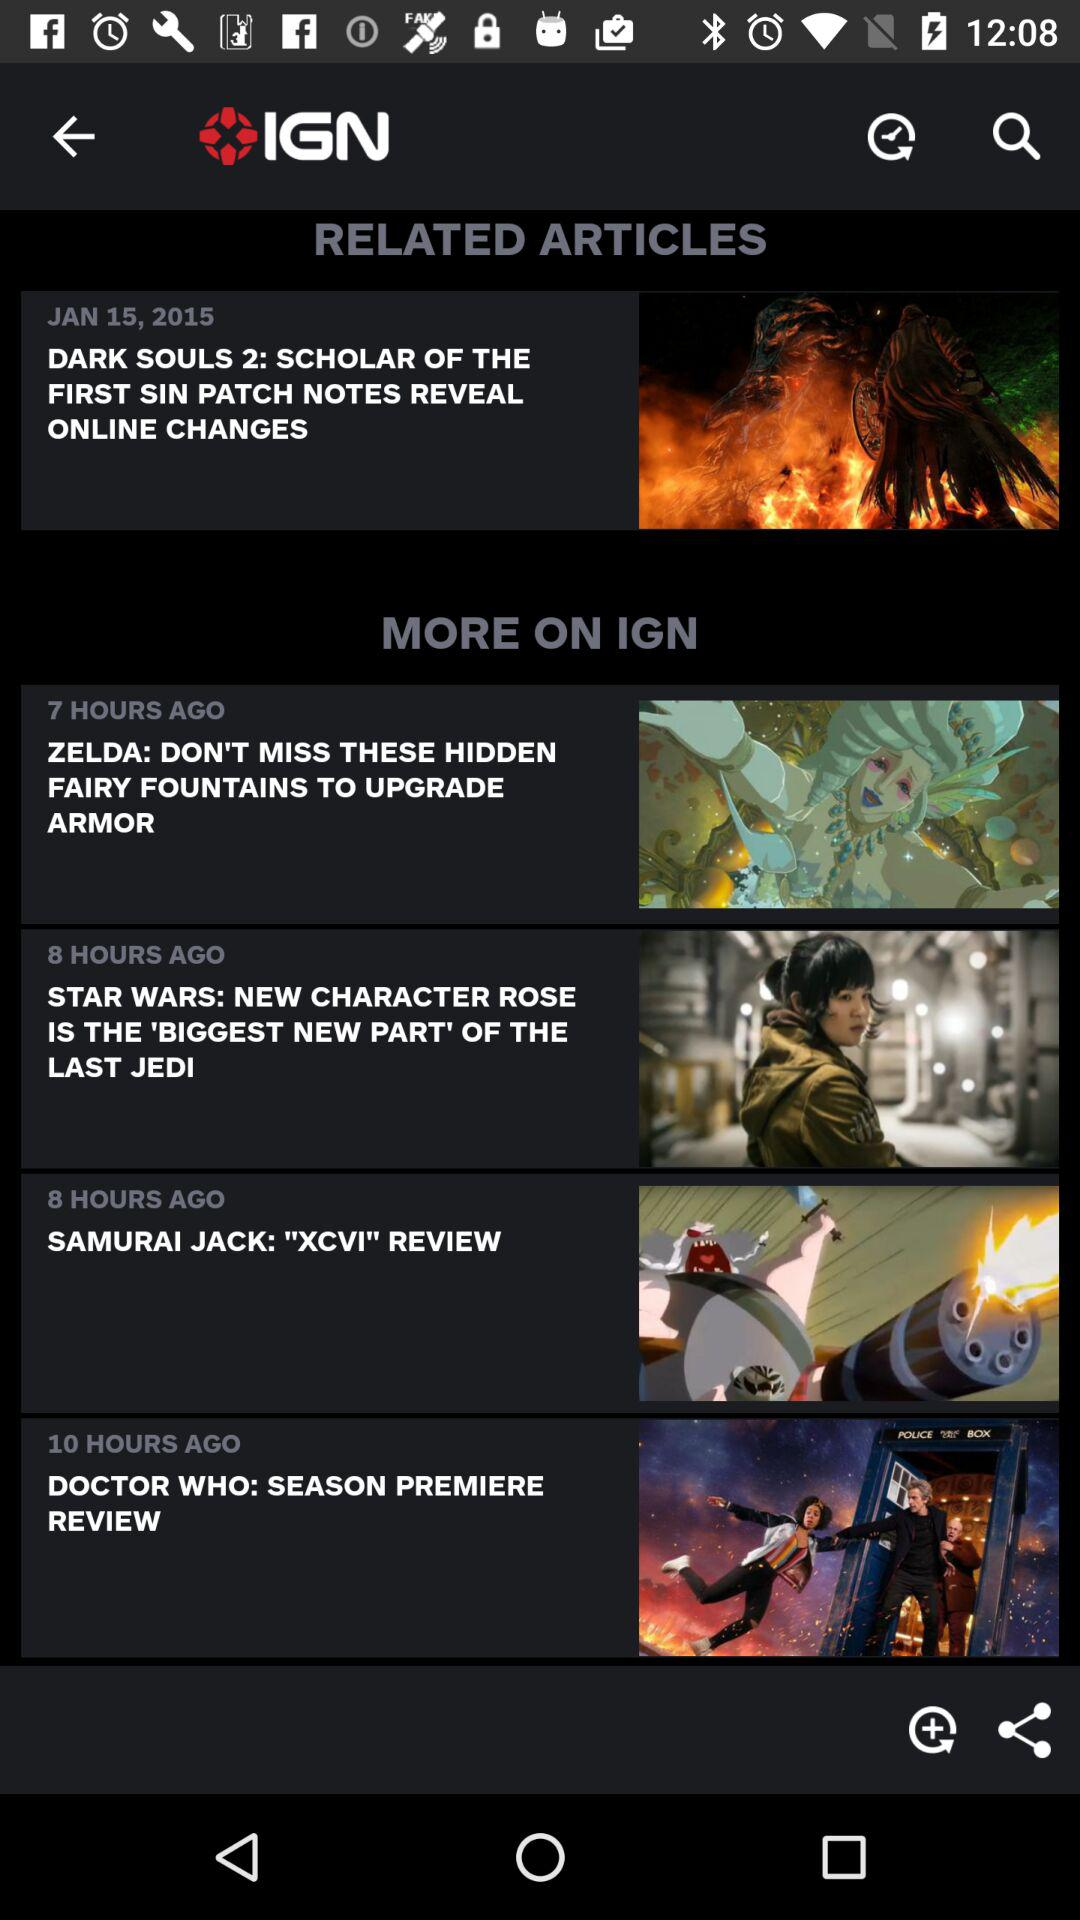How many hours ago was the article about Zelda published?
Answer the question using a single word or phrase. 7 hours ago 